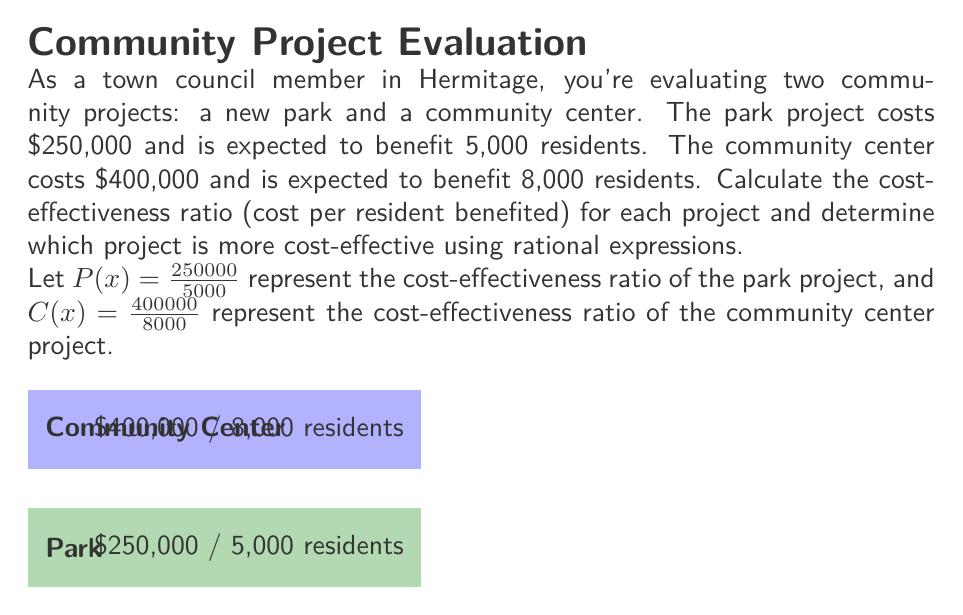Provide a solution to this math problem. To solve this problem, we need to calculate the cost-effectiveness ratio for each project and compare them:

1. For the park project:
   $P(x) = \frac{250000}{5000} = \frac{250}{5} = 50$

2. For the community center project:
   $C(x) = \frac{400000}{8000} = \frac{400}{8} = 50$

3. To compare the two ratios, we can subtract one from the other:
   $P(x) - C(x) = 50 - 50 = 0$

4. Since the difference is zero, both projects have the same cost-effectiveness ratio.

5. We can also express this comparison as a rational expression:
   $\frac{P(x)}{C(x)} = \frac{50}{50} = 1$

   This ratio of 1 confirms that both projects are equally cost-effective.

Therefore, both the park project and the community center project are equally cost-effective, with each costing $50 per resident benefited.
Answer: Both projects are equally cost-effective at $50 per resident. 